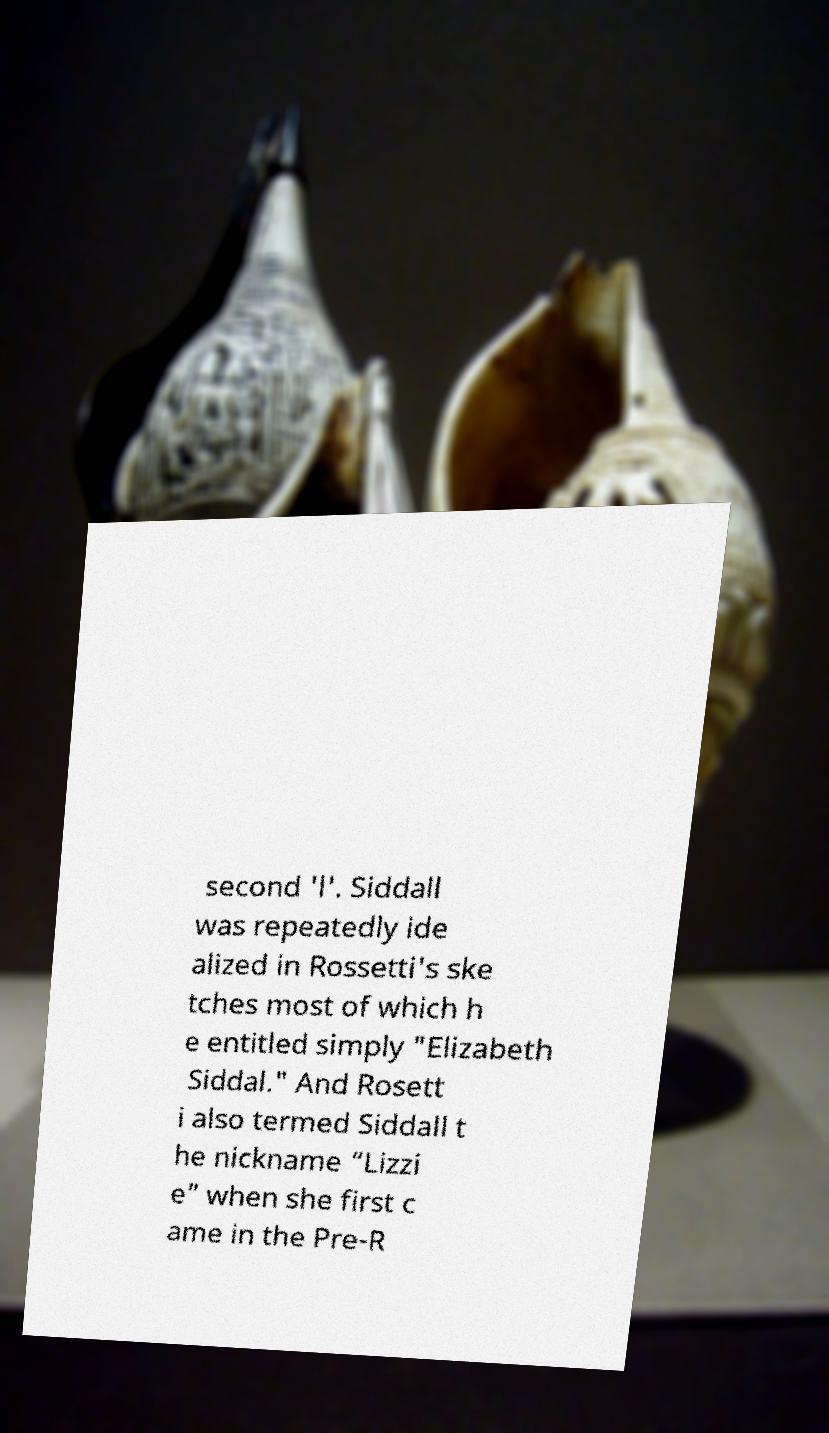Please read and relay the text visible in this image. What does it say? second 'l'. Siddall was repeatedly ide alized in Rossetti's ske tches most of which h e entitled simply "Elizabeth Siddal." And Rosett i also termed Siddall t he nickname “Lizzi e” when she first c ame in the Pre-R 